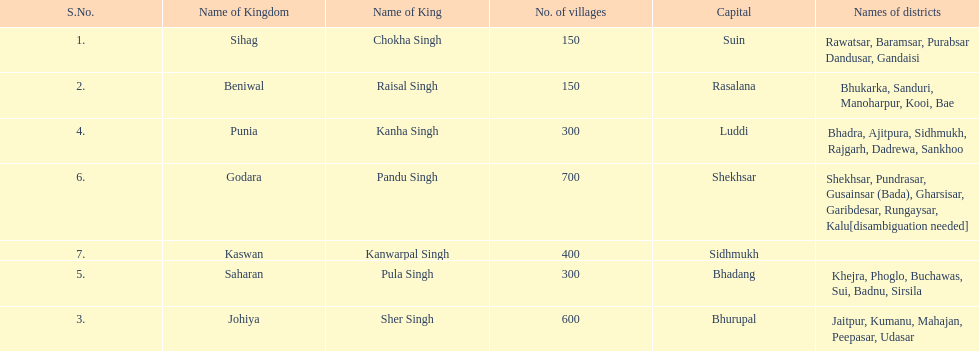What is the number of kingdoms that have more than 300 villages? 3. 